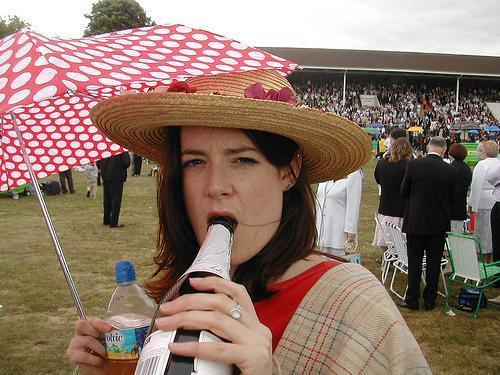How many women have on all white in the background?
Give a very brief answer. 2. How many people are holding umbrellas?
Give a very brief answer. 1. 